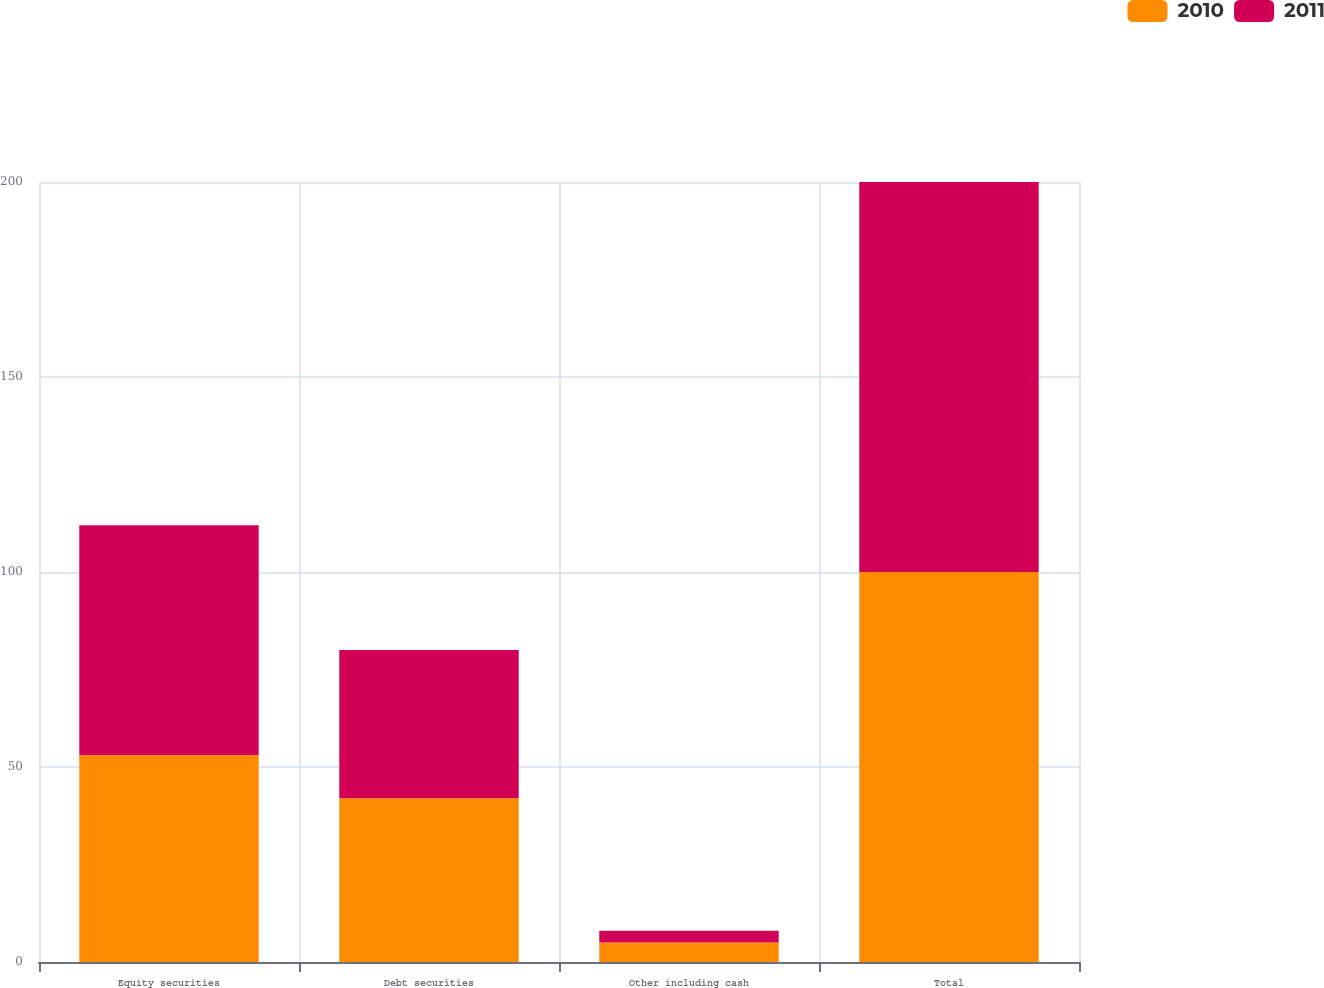<chart> <loc_0><loc_0><loc_500><loc_500><stacked_bar_chart><ecel><fcel>Equity securities<fcel>Debt securities<fcel>Other including cash<fcel>Total<nl><fcel>2010<fcel>53<fcel>42<fcel>5<fcel>100<nl><fcel>2011<fcel>59<fcel>38<fcel>3<fcel>100<nl></chart> 